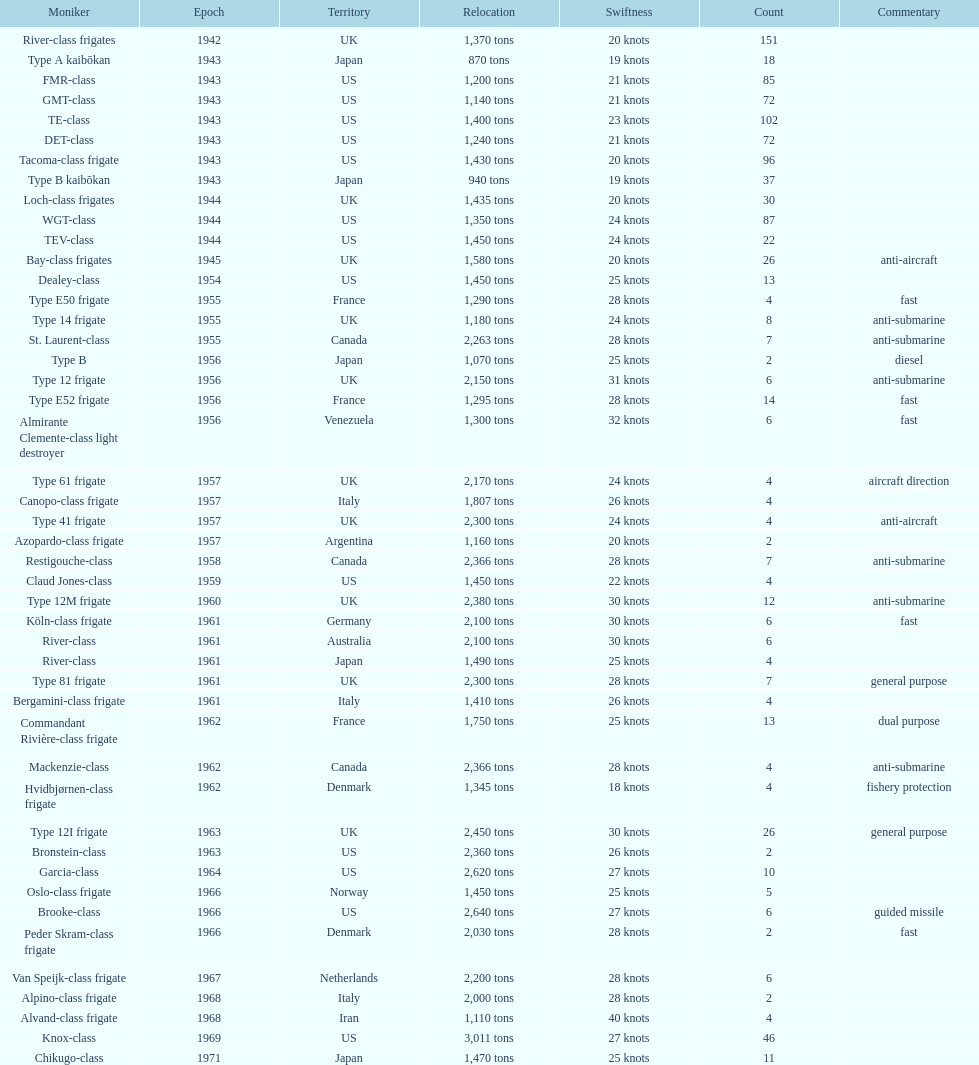How many consecutive escorts were in 1943? 7. 